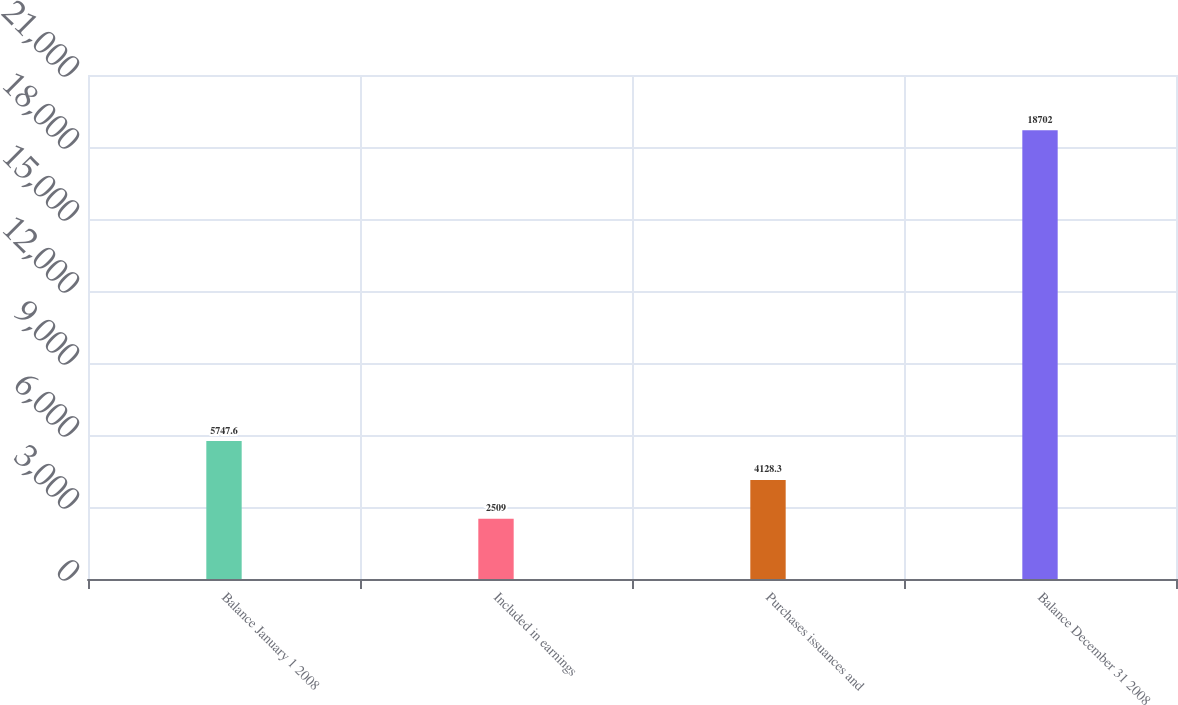Convert chart to OTSL. <chart><loc_0><loc_0><loc_500><loc_500><bar_chart><fcel>Balance January 1 2008<fcel>Included in earnings<fcel>Purchases issuances and<fcel>Balance December 31 2008<nl><fcel>5747.6<fcel>2509<fcel>4128.3<fcel>18702<nl></chart> 